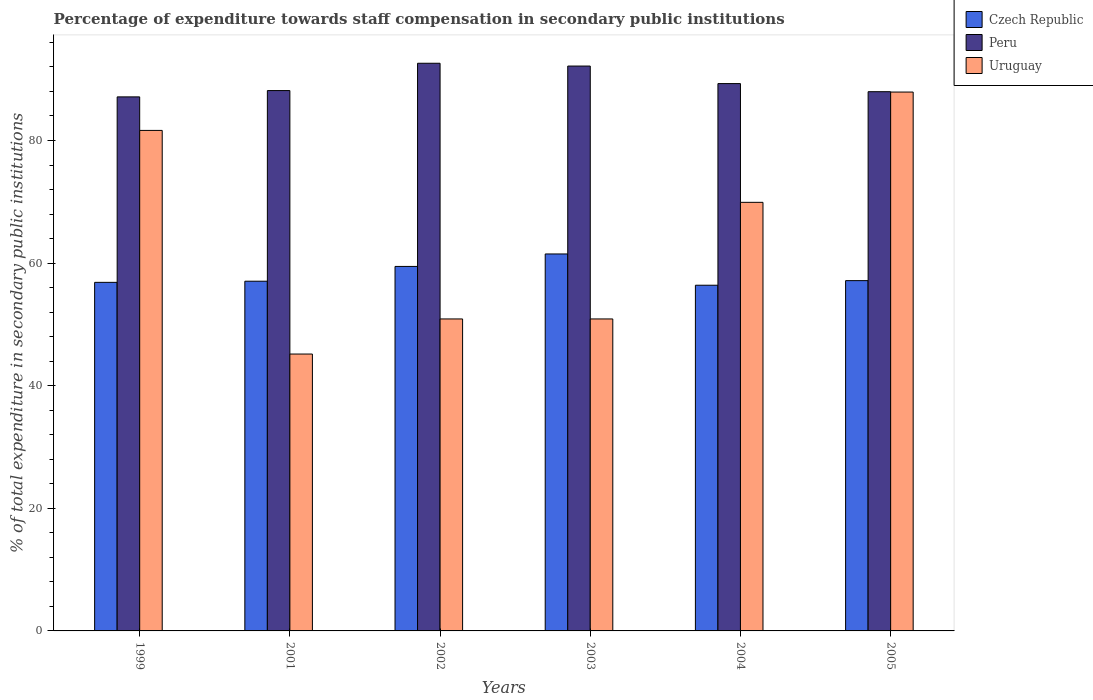Are the number of bars on each tick of the X-axis equal?
Your response must be concise. Yes. How many bars are there on the 3rd tick from the left?
Your answer should be very brief. 3. How many bars are there on the 5th tick from the right?
Provide a succinct answer. 3. In how many cases, is the number of bars for a given year not equal to the number of legend labels?
Provide a succinct answer. 0. What is the percentage of expenditure towards staff compensation in Peru in 1999?
Make the answer very short. 87.12. Across all years, what is the maximum percentage of expenditure towards staff compensation in Czech Republic?
Your answer should be compact. 61.49. Across all years, what is the minimum percentage of expenditure towards staff compensation in Czech Republic?
Keep it short and to the point. 56.39. What is the total percentage of expenditure towards staff compensation in Peru in the graph?
Provide a short and direct response. 537.25. What is the difference between the percentage of expenditure towards staff compensation in Czech Republic in 2004 and that in 2005?
Provide a short and direct response. -0.75. What is the difference between the percentage of expenditure towards staff compensation in Peru in 2003 and the percentage of expenditure towards staff compensation in Czech Republic in 2004?
Your answer should be very brief. 35.75. What is the average percentage of expenditure towards staff compensation in Uruguay per year?
Offer a terse response. 64.4. In the year 2002, what is the difference between the percentage of expenditure towards staff compensation in Czech Republic and percentage of expenditure towards staff compensation in Uruguay?
Your response must be concise. 8.57. What is the ratio of the percentage of expenditure towards staff compensation in Czech Republic in 1999 to that in 2005?
Your answer should be very brief. 1. Is the percentage of expenditure towards staff compensation in Peru in 2001 less than that in 2003?
Offer a very short reply. Yes. Is the difference between the percentage of expenditure towards staff compensation in Czech Republic in 1999 and 2001 greater than the difference between the percentage of expenditure towards staff compensation in Uruguay in 1999 and 2001?
Ensure brevity in your answer.  No. What is the difference between the highest and the second highest percentage of expenditure towards staff compensation in Czech Republic?
Provide a succinct answer. 2.03. What is the difference between the highest and the lowest percentage of expenditure towards staff compensation in Peru?
Offer a very short reply. 5.48. In how many years, is the percentage of expenditure towards staff compensation in Peru greater than the average percentage of expenditure towards staff compensation in Peru taken over all years?
Your answer should be compact. 2. What does the 1st bar from the left in 2001 represents?
Offer a terse response. Czech Republic. How many bars are there?
Offer a very short reply. 18. Does the graph contain grids?
Make the answer very short. No. Where does the legend appear in the graph?
Your response must be concise. Top right. How are the legend labels stacked?
Ensure brevity in your answer.  Vertical. What is the title of the graph?
Your answer should be compact. Percentage of expenditure towards staff compensation in secondary public institutions. What is the label or title of the Y-axis?
Your response must be concise. % of total expenditure in secondary public institutions. What is the % of total expenditure in secondary public institutions of Czech Republic in 1999?
Offer a very short reply. 56.86. What is the % of total expenditure in secondary public institutions of Peru in 1999?
Your answer should be very brief. 87.12. What is the % of total expenditure in secondary public institutions of Uruguay in 1999?
Ensure brevity in your answer.  81.65. What is the % of total expenditure in secondary public institutions in Czech Republic in 2001?
Provide a succinct answer. 57.05. What is the % of total expenditure in secondary public institutions of Peru in 2001?
Provide a succinct answer. 88.14. What is the % of total expenditure in secondary public institutions in Uruguay in 2001?
Provide a short and direct response. 45.17. What is the % of total expenditure in secondary public institutions of Czech Republic in 2002?
Your answer should be very brief. 59.46. What is the % of total expenditure in secondary public institutions of Peru in 2002?
Offer a terse response. 92.6. What is the % of total expenditure in secondary public institutions of Uruguay in 2002?
Your answer should be very brief. 50.89. What is the % of total expenditure in secondary public institutions in Czech Republic in 2003?
Provide a succinct answer. 61.49. What is the % of total expenditure in secondary public institutions in Peru in 2003?
Keep it short and to the point. 92.15. What is the % of total expenditure in secondary public institutions of Uruguay in 2003?
Provide a succinct answer. 50.89. What is the % of total expenditure in secondary public institutions of Czech Republic in 2004?
Give a very brief answer. 56.39. What is the % of total expenditure in secondary public institutions of Peru in 2004?
Keep it short and to the point. 89.28. What is the % of total expenditure in secondary public institutions of Uruguay in 2004?
Provide a succinct answer. 69.91. What is the % of total expenditure in secondary public institutions in Czech Republic in 2005?
Your response must be concise. 57.14. What is the % of total expenditure in secondary public institutions in Peru in 2005?
Make the answer very short. 87.96. What is the % of total expenditure in secondary public institutions in Uruguay in 2005?
Make the answer very short. 87.9. Across all years, what is the maximum % of total expenditure in secondary public institutions of Czech Republic?
Your answer should be compact. 61.49. Across all years, what is the maximum % of total expenditure in secondary public institutions of Peru?
Offer a very short reply. 92.6. Across all years, what is the maximum % of total expenditure in secondary public institutions of Uruguay?
Your answer should be compact. 87.9. Across all years, what is the minimum % of total expenditure in secondary public institutions of Czech Republic?
Your answer should be compact. 56.39. Across all years, what is the minimum % of total expenditure in secondary public institutions in Peru?
Provide a succinct answer. 87.12. Across all years, what is the minimum % of total expenditure in secondary public institutions of Uruguay?
Provide a succinct answer. 45.17. What is the total % of total expenditure in secondary public institutions in Czech Republic in the graph?
Your answer should be compact. 348.39. What is the total % of total expenditure in secondary public institutions of Peru in the graph?
Ensure brevity in your answer.  537.25. What is the total % of total expenditure in secondary public institutions in Uruguay in the graph?
Offer a terse response. 386.41. What is the difference between the % of total expenditure in secondary public institutions of Czech Republic in 1999 and that in 2001?
Offer a terse response. -0.19. What is the difference between the % of total expenditure in secondary public institutions in Peru in 1999 and that in 2001?
Give a very brief answer. -1.03. What is the difference between the % of total expenditure in secondary public institutions of Uruguay in 1999 and that in 2001?
Offer a terse response. 36.48. What is the difference between the % of total expenditure in secondary public institutions of Czech Republic in 1999 and that in 2002?
Give a very brief answer. -2.6. What is the difference between the % of total expenditure in secondary public institutions in Peru in 1999 and that in 2002?
Your answer should be very brief. -5.48. What is the difference between the % of total expenditure in secondary public institutions in Uruguay in 1999 and that in 2002?
Make the answer very short. 30.76. What is the difference between the % of total expenditure in secondary public institutions of Czech Republic in 1999 and that in 2003?
Make the answer very short. -4.63. What is the difference between the % of total expenditure in secondary public institutions in Peru in 1999 and that in 2003?
Make the answer very short. -5.03. What is the difference between the % of total expenditure in secondary public institutions in Uruguay in 1999 and that in 2003?
Offer a very short reply. 30.76. What is the difference between the % of total expenditure in secondary public institutions of Czech Republic in 1999 and that in 2004?
Give a very brief answer. 0.47. What is the difference between the % of total expenditure in secondary public institutions in Peru in 1999 and that in 2004?
Make the answer very short. -2.17. What is the difference between the % of total expenditure in secondary public institutions in Uruguay in 1999 and that in 2004?
Provide a short and direct response. 11.73. What is the difference between the % of total expenditure in secondary public institutions of Czech Republic in 1999 and that in 2005?
Ensure brevity in your answer.  -0.28. What is the difference between the % of total expenditure in secondary public institutions of Peru in 1999 and that in 2005?
Provide a short and direct response. -0.84. What is the difference between the % of total expenditure in secondary public institutions in Uruguay in 1999 and that in 2005?
Keep it short and to the point. -6.26. What is the difference between the % of total expenditure in secondary public institutions in Czech Republic in 2001 and that in 2002?
Your answer should be very brief. -2.41. What is the difference between the % of total expenditure in secondary public institutions in Peru in 2001 and that in 2002?
Keep it short and to the point. -4.46. What is the difference between the % of total expenditure in secondary public institutions in Uruguay in 2001 and that in 2002?
Offer a very short reply. -5.72. What is the difference between the % of total expenditure in secondary public institutions of Czech Republic in 2001 and that in 2003?
Offer a very short reply. -4.45. What is the difference between the % of total expenditure in secondary public institutions in Peru in 2001 and that in 2003?
Make the answer very short. -4. What is the difference between the % of total expenditure in secondary public institutions in Uruguay in 2001 and that in 2003?
Ensure brevity in your answer.  -5.72. What is the difference between the % of total expenditure in secondary public institutions of Czech Republic in 2001 and that in 2004?
Offer a very short reply. 0.65. What is the difference between the % of total expenditure in secondary public institutions of Peru in 2001 and that in 2004?
Ensure brevity in your answer.  -1.14. What is the difference between the % of total expenditure in secondary public institutions in Uruguay in 2001 and that in 2004?
Your answer should be compact. -24.75. What is the difference between the % of total expenditure in secondary public institutions of Czech Republic in 2001 and that in 2005?
Offer a very short reply. -0.09. What is the difference between the % of total expenditure in secondary public institutions in Peru in 2001 and that in 2005?
Keep it short and to the point. 0.18. What is the difference between the % of total expenditure in secondary public institutions in Uruguay in 2001 and that in 2005?
Your answer should be compact. -42.74. What is the difference between the % of total expenditure in secondary public institutions in Czech Republic in 2002 and that in 2003?
Offer a very short reply. -2.04. What is the difference between the % of total expenditure in secondary public institutions in Peru in 2002 and that in 2003?
Your answer should be very brief. 0.46. What is the difference between the % of total expenditure in secondary public institutions of Czech Republic in 2002 and that in 2004?
Ensure brevity in your answer.  3.06. What is the difference between the % of total expenditure in secondary public institutions in Peru in 2002 and that in 2004?
Ensure brevity in your answer.  3.32. What is the difference between the % of total expenditure in secondary public institutions in Uruguay in 2002 and that in 2004?
Make the answer very short. -19.02. What is the difference between the % of total expenditure in secondary public institutions of Czech Republic in 2002 and that in 2005?
Ensure brevity in your answer.  2.32. What is the difference between the % of total expenditure in secondary public institutions in Peru in 2002 and that in 2005?
Make the answer very short. 4.64. What is the difference between the % of total expenditure in secondary public institutions of Uruguay in 2002 and that in 2005?
Provide a succinct answer. -37.01. What is the difference between the % of total expenditure in secondary public institutions in Czech Republic in 2003 and that in 2004?
Offer a very short reply. 5.1. What is the difference between the % of total expenditure in secondary public institutions of Peru in 2003 and that in 2004?
Give a very brief answer. 2.86. What is the difference between the % of total expenditure in secondary public institutions of Uruguay in 2003 and that in 2004?
Keep it short and to the point. -19.02. What is the difference between the % of total expenditure in secondary public institutions of Czech Republic in 2003 and that in 2005?
Your answer should be very brief. 4.35. What is the difference between the % of total expenditure in secondary public institutions in Peru in 2003 and that in 2005?
Give a very brief answer. 4.18. What is the difference between the % of total expenditure in secondary public institutions of Uruguay in 2003 and that in 2005?
Keep it short and to the point. -37.01. What is the difference between the % of total expenditure in secondary public institutions of Czech Republic in 2004 and that in 2005?
Provide a succinct answer. -0.75. What is the difference between the % of total expenditure in secondary public institutions of Peru in 2004 and that in 2005?
Make the answer very short. 1.32. What is the difference between the % of total expenditure in secondary public institutions of Uruguay in 2004 and that in 2005?
Offer a very short reply. -17.99. What is the difference between the % of total expenditure in secondary public institutions in Czech Republic in 1999 and the % of total expenditure in secondary public institutions in Peru in 2001?
Ensure brevity in your answer.  -31.28. What is the difference between the % of total expenditure in secondary public institutions in Czech Republic in 1999 and the % of total expenditure in secondary public institutions in Uruguay in 2001?
Provide a succinct answer. 11.7. What is the difference between the % of total expenditure in secondary public institutions in Peru in 1999 and the % of total expenditure in secondary public institutions in Uruguay in 2001?
Your response must be concise. 41.95. What is the difference between the % of total expenditure in secondary public institutions in Czech Republic in 1999 and the % of total expenditure in secondary public institutions in Peru in 2002?
Your response must be concise. -35.74. What is the difference between the % of total expenditure in secondary public institutions in Czech Republic in 1999 and the % of total expenditure in secondary public institutions in Uruguay in 2002?
Offer a very short reply. 5.97. What is the difference between the % of total expenditure in secondary public institutions of Peru in 1999 and the % of total expenditure in secondary public institutions of Uruguay in 2002?
Your answer should be very brief. 36.23. What is the difference between the % of total expenditure in secondary public institutions of Czech Republic in 1999 and the % of total expenditure in secondary public institutions of Peru in 2003?
Your answer should be very brief. -35.28. What is the difference between the % of total expenditure in secondary public institutions of Czech Republic in 1999 and the % of total expenditure in secondary public institutions of Uruguay in 2003?
Your response must be concise. 5.97. What is the difference between the % of total expenditure in secondary public institutions in Peru in 1999 and the % of total expenditure in secondary public institutions in Uruguay in 2003?
Your response must be concise. 36.23. What is the difference between the % of total expenditure in secondary public institutions in Czech Republic in 1999 and the % of total expenditure in secondary public institutions in Peru in 2004?
Give a very brief answer. -32.42. What is the difference between the % of total expenditure in secondary public institutions of Czech Republic in 1999 and the % of total expenditure in secondary public institutions of Uruguay in 2004?
Your answer should be compact. -13.05. What is the difference between the % of total expenditure in secondary public institutions in Peru in 1999 and the % of total expenditure in secondary public institutions in Uruguay in 2004?
Provide a short and direct response. 17.2. What is the difference between the % of total expenditure in secondary public institutions in Czech Republic in 1999 and the % of total expenditure in secondary public institutions in Peru in 2005?
Give a very brief answer. -31.1. What is the difference between the % of total expenditure in secondary public institutions in Czech Republic in 1999 and the % of total expenditure in secondary public institutions in Uruguay in 2005?
Make the answer very short. -31.04. What is the difference between the % of total expenditure in secondary public institutions of Peru in 1999 and the % of total expenditure in secondary public institutions of Uruguay in 2005?
Your response must be concise. -0.79. What is the difference between the % of total expenditure in secondary public institutions in Czech Republic in 2001 and the % of total expenditure in secondary public institutions in Peru in 2002?
Provide a succinct answer. -35.55. What is the difference between the % of total expenditure in secondary public institutions of Czech Republic in 2001 and the % of total expenditure in secondary public institutions of Uruguay in 2002?
Offer a terse response. 6.16. What is the difference between the % of total expenditure in secondary public institutions in Peru in 2001 and the % of total expenditure in secondary public institutions in Uruguay in 2002?
Make the answer very short. 37.25. What is the difference between the % of total expenditure in secondary public institutions in Czech Republic in 2001 and the % of total expenditure in secondary public institutions in Peru in 2003?
Provide a succinct answer. -35.1. What is the difference between the % of total expenditure in secondary public institutions of Czech Republic in 2001 and the % of total expenditure in secondary public institutions of Uruguay in 2003?
Provide a succinct answer. 6.16. What is the difference between the % of total expenditure in secondary public institutions of Peru in 2001 and the % of total expenditure in secondary public institutions of Uruguay in 2003?
Offer a very short reply. 37.25. What is the difference between the % of total expenditure in secondary public institutions of Czech Republic in 2001 and the % of total expenditure in secondary public institutions of Peru in 2004?
Make the answer very short. -32.24. What is the difference between the % of total expenditure in secondary public institutions of Czech Republic in 2001 and the % of total expenditure in secondary public institutions of Uruguay in 2004?
Offer a very short reply. -12.87. What is the difference between the % of total expenditure in secondary public institutions of Peru in 2001 and the % of total expenditure in secondary public institutions of Uruguay in 2004?
Provide a succinct answer. 18.23. What is the difference between the % of total expenditure in secondary public institutions in Czech Republic in 2001 and the % of total expenditure in secondary public institutions in Peru in 2005?
Offer a terse response. -30.91. What is the difference between the % of total expenditure in secondary public institutions in Czech Republic in 2001 and the % of total expenditure in secondary public institutions in Uruguay in 2005?
Provide a succinct answer. -30.86. What is the difference between the % of total expenditure in secondary public institutions in Peru in 2001 and the % of total expenditure in secondary public institutions in Uruguay in 2005?
Make the answer very short. 0.24. What is the difference between the % of total expenditure in secondary public institutions in Czech Republic in 2002 and the % of total expenditure in secondary public institutions in Peru in 2003?
Provide a succinct answer. -32.69. What is the difference between the % of total expenditure in secondary public institutions in Czech Republic in 2002 and the % of total expenditure in secondary public institutions in Uruguay in 2003?
Offer a very short reply. 8.57. What is the difference between the % of total expenditure in secondary public institutions in Peru in 2002 and the % of total expenditure in secondary public institutions in Uruguay in 2003?
Ensure brevity in your answer.  41.71. What is the difference between the % of total expenditure in secondary public institutions in Czech Republic in 2002 and the % of total expenditure in secondary public institutions in Peru in 2004?
Provide a succinct answer. -29.83. What is the difference between the % of total expenditure in secondary public institutions in Czech Republic in 2002 and the % of total expenditure in secondary public institutions in Uruguay in 2004?
Your answer should be compact. -10.46. What is the difference between the % of total expenditure in secondary public institutions of Peru in 2002 and the % of total expenditure in secondary public institutions of Uruguay in 2004?
Offer a very short reply. 22.69. What is the difference between the % of total expenditure in secondary public institutions of Czech Republic in 2002 and the % of total expenditure in secondary public institutions of Peru in 2005?
Provide a short and direct response. -28.5. What is the difference between the % of total expenditure in secondary public institutions of Czech Republic in 2002 and the % of total expenditure in secondary public institutions of Uruguay in 2005?
Make the answer very short. -28.45. What is the difference between the % of total expenditure in secondary public institutions in Peru in 2002 and the % of total expenditure in secondary public institutions in Uruguay in 2005?
Give a very brief answer. 4.7. What is the difference between the % of total expenditure in secondary public institutions in Czech Republic in 2003 and the % of total expenditure in secondary public institutions in Peru in 2004?
Ensure brevity in your answer.  -27.79. What is the difference between the % of total expenditure in secondary public institutions of Czech Republic in 2003 and the % of total expenditure in secondary public institutions of Uruguay in 2004?
Offer a very short reply. -8.42. What is the difference between the % of total expenditure in secondary public institutions in Peru in 2003 and the % of total expenditure in secondary public institutions in Uruguay in 2004?
Offer a terse response. 22.23. What is the difference between the % of total expenditure in secondary public institutions of Czech Republic in 2003 and the % of total expenditure in secondary public institutions of Peru in 2005?
Your answer should be compact. -26.47. What is the difference between the % of total expenditure in secondary public institutions of Czech Republic in 2003 and the % of total expenditure in secondary public institutions of Uruguay in 2005?
Provide a succinct answer. -26.41. What is the difference between the % of total expenditure in secondary public institutions of Peru in 2003 and the % of total expenditure in secondary public institutions of Uruguay in 2005?
Ensure brevity in your answer.  4.24. What is the difference between the % of total expenditure in secondary public institutions of Czech Republic in 2004 and the % of total expenditure in secondary public institutions of Peru in 2005?
Make the answer very short. -31.57. What is the difference between the % of total expenditure in secondary public institutions in Czech Republic in 2004 and the % of total expenditure in secondary public institutions in Uruguay in 2005?
Your response must be concise. -31.51. What is the difference between the % of total expenditure in secondary public institutions of Peru in 2004 and the % of total expenditure in secondary public institutions of Uruguay in 2005?
Ensure brevity in your answer.  1.38. What is the average % of total expenditure in secondary public institutions in Czech Republic per year?
Your answer should be compact. 58.07. What is the average % of total expenditure in secondary public institutions in Peru per year?
Your response must be concise. 89.54. What is the average % of total expenditure in secondary public institutions in Uruguay per year?
Keep it short and to the point. 64.4. In the year 1999, what is the difference between the % of total expenditure in secondary public institutions in Czech Republic and % of total expenditure in secondary public institutions in Peru?
Your answer should be very brief. -30.26. In the year 1999, what is the difference between the % of total expenditure in secondary public institutions in Czech Republic and % of total expenditure in secondary public institutions in Uruguay?
Ensure brevity in your answer.  -24.79. In the year 1999, what is the difference between the % of total expenditure in secondary public institutions of Peru and % of total expenditure in secondary public institutions of Uruguay?
Your answer should be compact. 5.47. In the year 2001, what is the difference between the % of total expenditure in secondary public institutions in Czech Republic and % of total expenditure in secondary public institutions in Peru?
Your response must be concise. -31.1. In the year 2001, what is the difference between the % of total expenditure in secondary public institutions of Czech Republic and % of total expenditure in secondary public institutions of Uruguay?
Your response must be concise. 11.88. In the year 2001, what is the difference between the % of total expenditure in secondary public institutions in Peru and % of total expenditure in secondary public institutions in Uruguay?
Provide a succinct answer. 42.98. In the year 2002, what is the difference between the % of total expenditure in secondary public institutions of Czech Republic and % of total expenditure in secondary public institutions of Peru?
Make the answer very short. -33.14. In the year 2002, what is the difference between the % of total expenditure in secondary public institutions of Czech Republic and % of total expenditure in secondary public institutions of Uruguay?
Provide a short and direct response. 8.57. In the year 2002, what is the difference between the % of total expenditure in secondary public institutions in Peru and % of total expenditure in secondary public institutions in Uruguay?
Offer a terse response. 41.71. In the year 2003, what is the difference between the % of total expenditure in secondary public institutions of Czech Republic and % of total expenditure in secondary public institutions of Peru?
Offer a terse response. -30.65. In the year 2003, what is the difference between the % of total expenditure in secondary public institutions in Czech Republic and % of total expenditure in secondary public institutions in Uruguay?
Keep it short and to the point. 10.6. In the year 2003, what is the difference between the % of total expenditure in secondary public institutions of Peru and % of total expenditure in secondary public institutions of Uruguay?
Your answer should be compact. 41.26. In the year 2004, what is the difference between the % of total expenditure in secondary public institutions in Czech Republic and % of total expenditure in secondary public institutions in Peru?
Your answer should be very brief. -32.89. In the year 2004, what is the difference between the % of total expenditure in secondary public institutions of Czech Republic and % of total expenditure in secondary public institutions of Uruguay?
Offer a very short reply. -13.52. In the year 2004, what is the difference between the % of total expenditure in secondary public institutions in Peru and % of total expenditure in secondary public institutions in Uruguay?
Keep it short and to the point. 19.37. In the year 2005, what is the difference between the % of total expenditure in secondary public institutions of Czech Republic and % of total expenditure in secondary public institutions of Peru?
Ensure brevity in your answer.  -30.82. In the year 2005, what is the difference between the % of total expenditure in secondary public institutions in Czech Republic and % of total expenditure in secondary public institutions in Uruguay?
Offer a very short reply. -30.76. In the year 2005, what is the difference between the % of total expenditure in secondary public institutions of Peru and % of total expenditure in secondary public institutions of Uruguay?
Your answer should be compact. 0.06. What is the ratio of the % of total expenditure in secondary public institutions in Czech Republic in 1999 to that in 2001?
Your answer should be very brief. 1. What is the ratio of the % of total expenditure in secondary public institutions of Peru in 1999 to that in 2001?
Keep it short and to the point. 0.99. What is the ratio of the % of total expenditure in secondary public institutions of Uruguay in 1999 to that in 2001?
Give a very brief answer. 1.81. What is the ratio of the % of total expenditure in secondary public institutions of Czech Republic in 1999 to that in 2002?
Offer a terse response. 0.96. What is the ratio of the % of total expenditure in secondary public institutions of Peru in 1999 to that in 2002?
Give a very brief answer. 0.94. What is the ratio of the % of total expenditure in secondary public institutions in Uruguay in 1999 to that in 2002?
Give a very brief answer. 1.6. What is the ratio of the % of total expenditure in secondary public institutions of Czech Republic in 1999 to that in 2003?
Your response must be concise. 0.92. What is the ratio of the % of total expenditure in secondary public institutions in Peru in 1999 to that in 2003?
Your answer should be very brief. 0.95. What is the ratio of the % of total expenditure in secondary public institutions in Uruguay in 1999 to that in 2003?
Keep it short and to the point. 1.6. What is the ratio of the % of total expenditure in secondary public institutions in Czech Republic in 1999 to that in 2004?
Offer a terse response. 1.01. What is the ratio of the % of total expenditure in secondary public institutions in Peru in 1999 to that in 2004?
Your answer should be very brief. 0.98. What is the ratio of the % of total expenditure in secondary public institutions in Uruguay in 1999 to that in 2004?
Offer a terse response. 1.17. What is the ratio of the % of total expenditure in secondary public institutions of Peru in 1999 to that in 2005?
Offer a very short reply. 0.99. What is the ratio of the % of total expenditure in secondary public institutions of Uruguay in 1999 to that in 2005?
Ensure brevity in your answer.  0.93. What is the ratio of the % of total expenditure in secondary public institutions in Czech Republic in 2001 to that in 2002?
Provide a short and direct response. 0.96. What is the ratio of the % of total expenditure in secondary public institutions in Peru in 2001 to that in 2002?
Your answer should be very brief. 0.95. What is the ratio of the % of total expenditure in secondary public institutions of Uruguay in 2001 to that in 2002?
Provide a short and direct response. 0.89. What is the ratio of the % of total expenditure in secondary public institutions in Czech Republic in 2001 to that in 2003?
Your answer should be very brief. 0.93. What is the ratio of the % of total expenditure in secondary public institutions in Peru in 2001 to that in 2003?
Offer a very short reply. 0.96. What is the ratio of the % of total expenditure in secondary public institutions in Uruguay in 2001 to that in 2003?
Ensure brevity in your answer.  0.89. What is the ratio of the % of total expenditure in secondary public institutions in Czech Republic in 2001 to that in 2004?
Ensure brevity in your answer.  1.01. What is the ratio of the % of total expenditure in secondary public institutions of Peru in 2001 to that in 2004?
Your answer should be very brief. 0.99. What is the ratio of the % of total expenditure in secondary public institutions in Uruguay in 2001 to that in 2004?
Make the answer very short. 0.65. What is the ratio of the % of total expenditure in secondary public institutions in Uruguay in 2001 to that in 2005?
Offer a very short reply. 0.51. What is the ratio of the % of total expenditure in secondary public institutions of Czech Republic in 2002 to that in 2003?
Your response must be concise. 0.97. What is the ratio of the % of total expenditure in secondary public institutions of Peru in 2002 to that in 2003?
Offer a very short reply. 1. What is the ratio of the % of total expenditure in secondary public institutions in Uruguay in 2002 to that in 2003?
Provide a succinct answer. 1. What is the ratio of the % of total expenditure in secondary public institutions of Czech Republic in 2002 to that in 2004?
Make the answer very short. 1.05. What is the ratio of the % of total expenditure in secondary public institutions of Peru in 2002 to that in 2004?
Your answer should be compact. 1.04. What is the ratio of the % of total expenditure in secondary public institutions in Uruguay in 2002 to that in 2004?
Offer a terse response. 0.73. What is the ratio of the % of total expenditure in secondary public institutions in Czech Republic in 2002 to that in 2005?
Your answer should be very brief. 1.04. What is the ratio of the % of total expenditure in secondary public institutions in Peru in 2002 to that in 2005?
Make the answer very short. 1.05. What is the ratio of the % of total expenditure in secondary public institutions in Uruguay in 2002 to that in 2005?
Give a very brief answer. 0.58. What is the ratio of the % of total expenditure in secondary public institutions of Czech Republic in 2003 to that in 2004?
Make the answer very short. 1.09. What is the ratio of the % of total expenditure in secondary public institutions of Peru in 2003 to that in 2004?
Make the answer very short. 1.03. What is the ratio of the % of total expenditure in secondary public institutions of Uruguay in 2003 to that in 2004?
Offer a very short reply. 0.73. What is the ratio of the % of total expenditure in secondary public institutions of Czech Republic in 2003 to that in 2005?
Provide a short and direct response. 1.08. What is the ratio of the % of total expenditure in secondary public institutions in Peru in 2003 to that in 2005?
Offer a very short reply. 1.05. What is the ratio of the % of total expenditure in secondary public institutions of Uruguay in 2003 to that in 2005?
Offer a terse response. 0.58. What is the ratio of the % of total expenditure in secondary public institutions of Czech Republic in 2004 to that in 2005?
Offer a terse response. 0.99. What is the ratio of the % of total expenditure in secondary public institutions of Peru in 2004 to that in 2005?
Offer a very short reply. 1.01. What is the ratio of the % of total expenditure in secondary public institutions of Uruguay in 2004 to that in 2005?
Offer a very short reply. 0.8. What is the difference between the highest and the second highest % of total expenditure in secondary public institutions in Czech Republic?
Ensure brevity in your answer.  2.04. What is the difference between the highest and the second highest % of total expenditure in secondary public institutions of Peru?
Your answer should be very brief. 0.46. What is the difference between the highest and the second highest % of total expenditure in secondary public institutions of Uruguay?
Offer a very short reply. 6.26. What is the difference between the highest and the lowest % of total expenditure in secondary public institutions in Czech Republic?
Offer a terse response. 5.1. What is the difference between the highest and the lowest % of total expenditure in secondary public institutions in Peru?
Offer a very short reply. 5.48. What is the difference between the highest and the lowest % of total expenditure in secondary public institutions in Uruguay?
Your answer should be very brief. 42.74. 